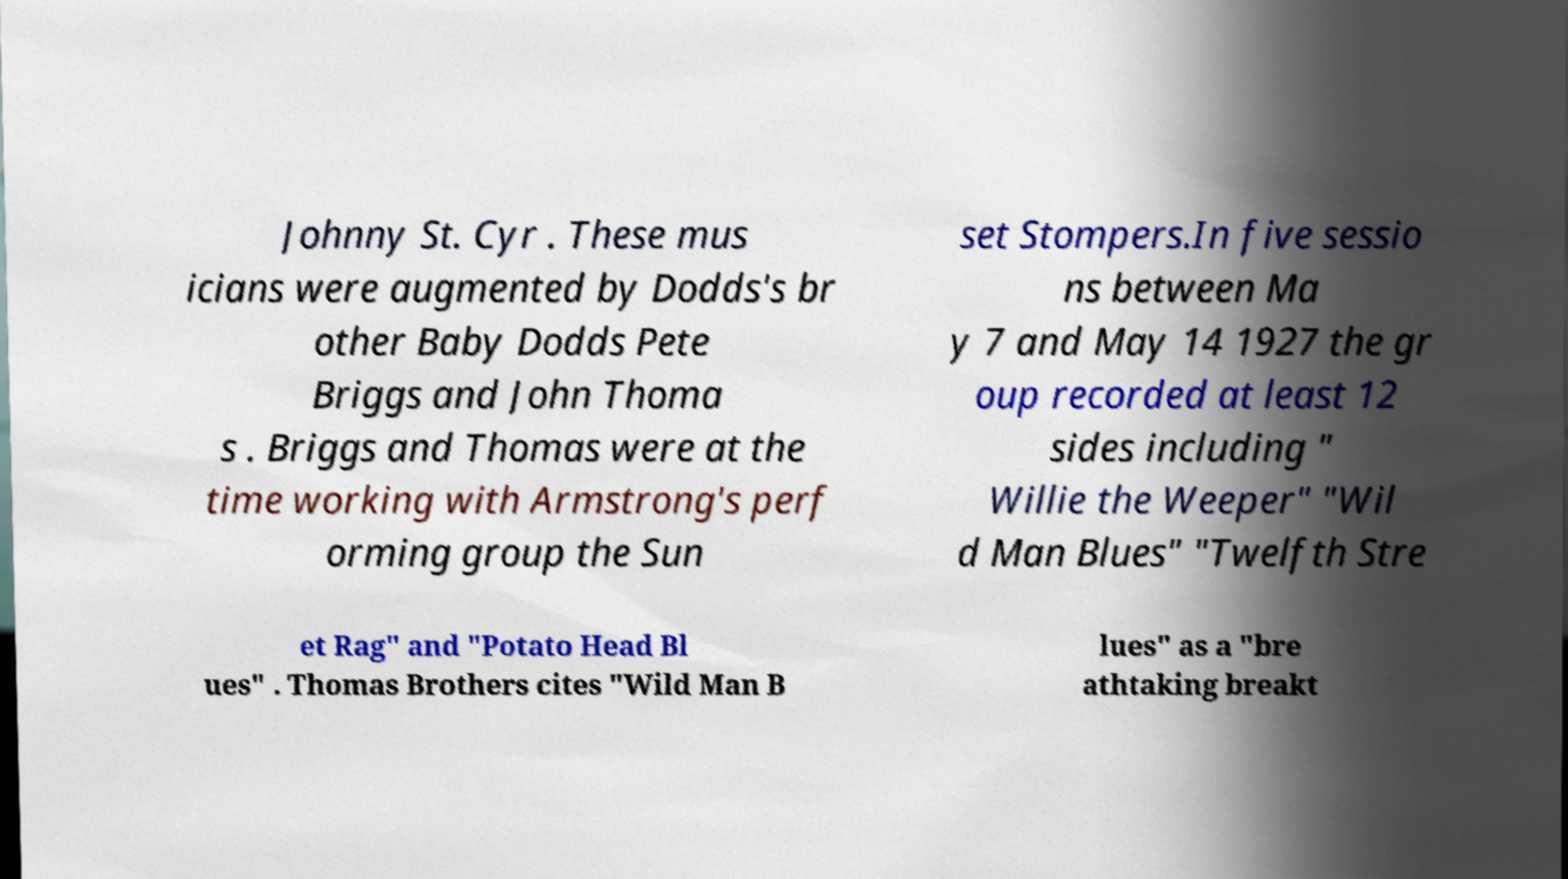Please identify and transcribe the text found in this image. Johnny St. Cyr . These mus icians were augmented by Dodds's br other Baby Dodds Pete Briggs and John Thoma s . Briggs and Thomas were at the time working with Armstrong's perf orming group the Sun set Stompers.In five sessio ns between Ma y 7 and May 14 1927 the gr oup recorded at least 12 sides including " Willie the Weeper" "Wil d Man Blues" "Twelfth Stre et Rag" and "Potato Head Bl ues" . Thomas Brothers cites "Wild Man B lues" as a "bre athtaking breakt 